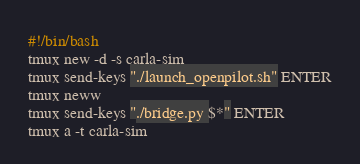<code> <loc_0><loc_0><loc_500><loc_500><_Bash_>#!/bin/bash
tmux new -d -s carla-sim
tmux send-keys "./launch_openpilot.sh" ENTER
tmux neww
tmux send-keys "./bridge.py $*" ENTER
tmux a -t carla-sim
</code> 